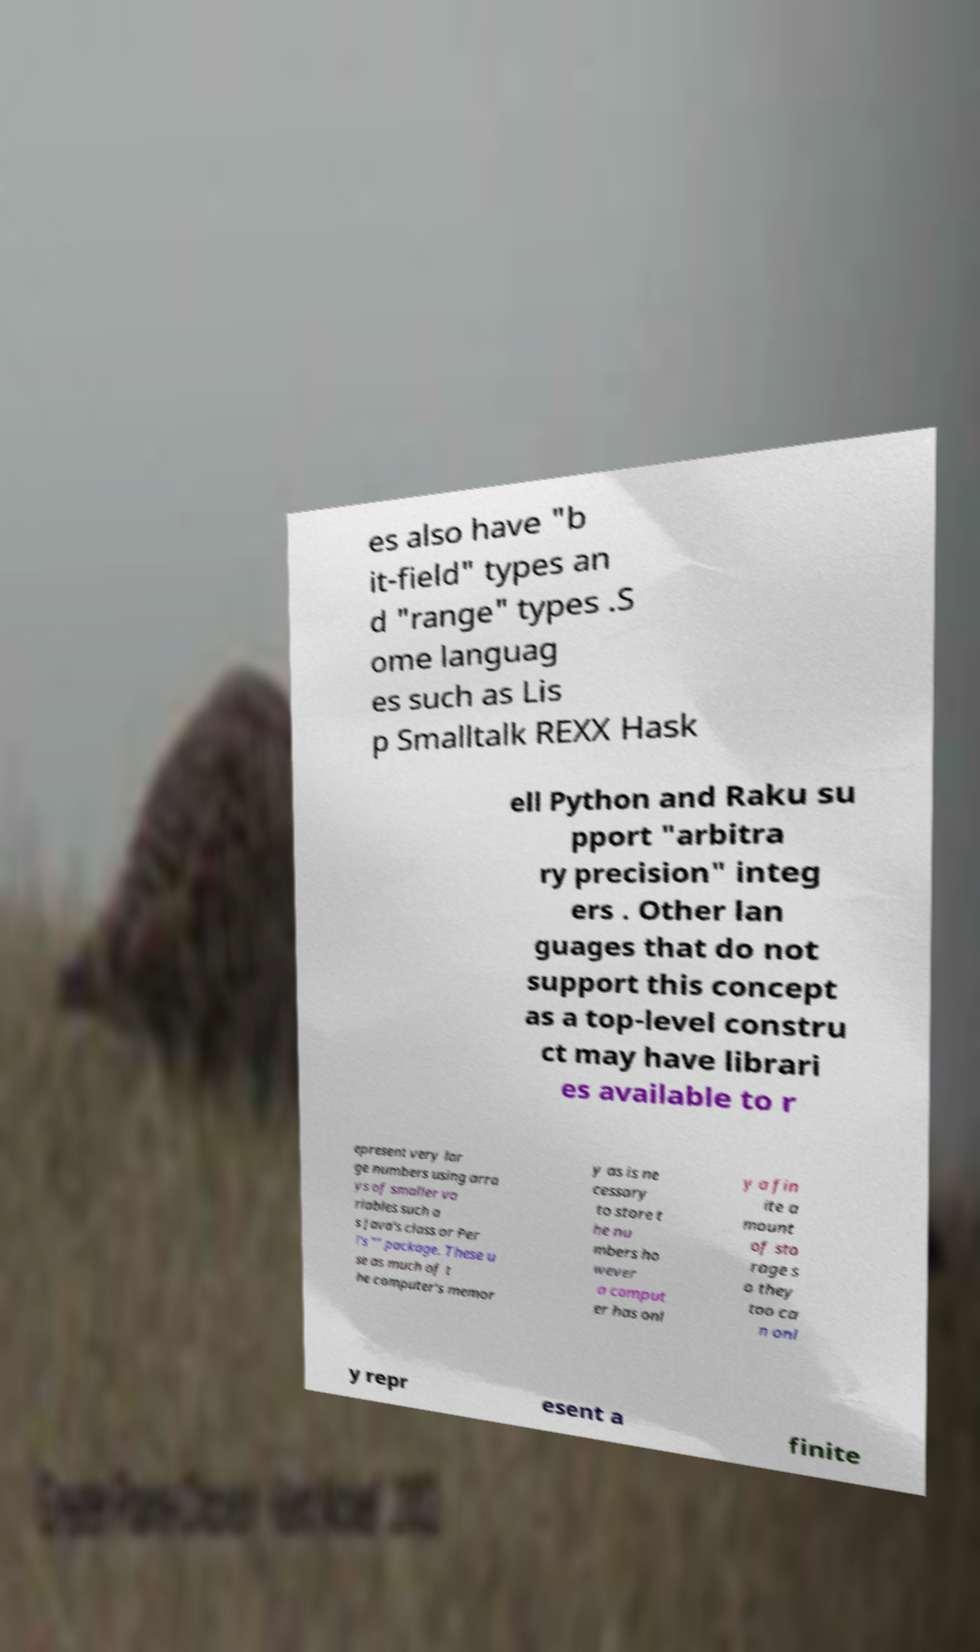What messages or text are displayed in this image? I need them in a readable, typed format. es also have "b it-field" types an d "range" types .S ome languag es such as Lis p Smalltalk REXX Hask ell Python and Raku su pport "arbitra ry precision" integ ers . Other lan guages that do not support this concept as a top-level constru ct may have librari es available to r epresent very lar ge numbers using arra ys of smaller va riables such a s Java's class or Per l's "" package. These u se as much of t he computer's memor y as is ne cessary to store t he nu mbers ho wever a comput er has onl y a fin ite a mount of sto rage s o they too ca n onl y repr esent a finite 